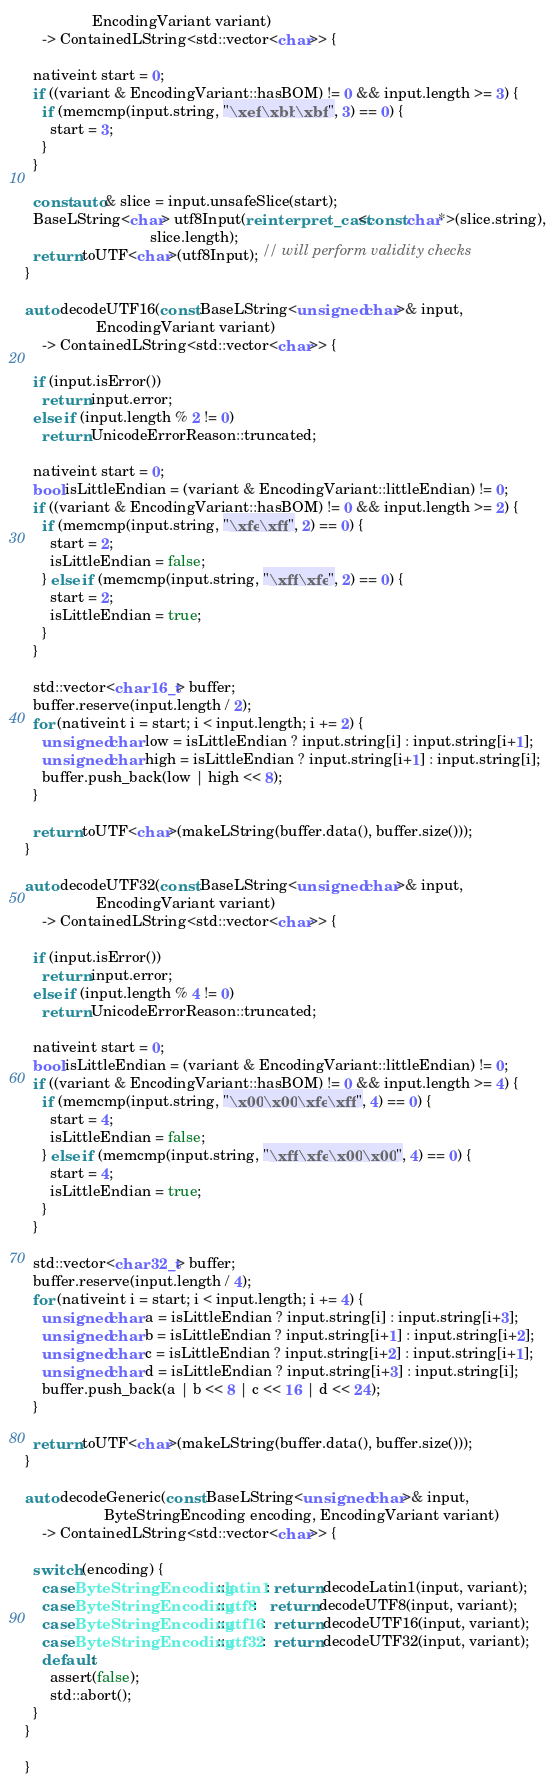<code> <loc_0><loc_0><loc_500><loc_500><_C++_>                EncodingVariant variant)
    -> ContainedLString<std::vector<char>> {

  nativeint start = 0;
  if ((variant & EncodingVariant::hasBOM) != 0 && input.length >= 3) {
    if (memcmp(input.string, "\xef\xbb\xbf", 3) == 0) {
      start = 3;
    }
  }

  const auto& slice = input.unsafeSlice(start);
  BaseLString<char> utf8Input(reinterpret_cast<const char*>(slice.string),
                              slice.length);
  return toUTF<char>(utf8Input); // will perform validity checks
}

auto decodeUTF16(const BaseLString<unsigned char>& input,
                 EncodingVariant variant)
    -> ContainedLString<std::vector<char>> {

  if (input.isError())
    return input.error;
  else if (input.length % 2 != 0)
    return UnicodeErrorReason::truncated;

  nativeint start = 0;
  bool isLittleEndian = (variant & EncodingVariant::littleEndian) != 0;
  if ((variant & EncodingVariant::hasBOM) != 0 && input.length >= 2) {
    if (memcmp(input.string, "\xfe\xff", 2) == 0) {
      start = 2;
      isLittleEndian = false;
    } else if (memcmp(input.string, "\xff\xfe", 2) == 0) {
      start = 2;
      isLittleEndian = true;
    }
  }

  std::vector<char16_t> buffer;
  buffer.reserve(input.length / 2);
  for (nativeint i = start; i < input.length; i += 2) {
    unsigned char low = isLittleEndian ? input.string[i] : input.string[i+1];
    unsigned char high = isLittleEndian ? input.string[i+1] : input.string[i];
    buffer.push_back(low | high << 8);
  }

  return toUTF<char>(makeLString(buffer.data(), buffer.size()));
}

auto decodeUTF32(const BaseLString<unsigned char>& input,
                 EncodingVariant variant)
    -> ContainedLString<std::vector<char>> {

  if (input.isError())
    return input.error;
  else if (input.length % 4 != 0)
    return UnicodeErrorReason::truncated;

  nativeint start = 0;
  bool isLittleEndian = (variant & EncodingVariant::littleEndian) != 0;
  if ((variant & EncodingVariant::hasBOM) != 0 && input.length >= 4) {
    if (memcmp(input.string, "\x00\x00\xfe\xff", 4) == 0) {
      start = 4;
      isLittleEndian = false;
    } else if (memcmp(input.string, "\xff\xfe\x00\x00", 4) == 0) {
      start = 4;
      isLittleEndian = true;
    }
  }

  std::vector<char32_t> buffer;
  buffer.reserve(input.length / 4);
  for (nativeint i = start; i < input.length; i += 4) {
    unsigned char a = isLittleEndian ? input.string[i] : input.string[i+3];
    unsigned char b = isLittleEndian ? input.string[i+1] : input.string[i+2];
    unsigned char c = isLittleEndian ? input.string[i+2] : input.string[i+1];
    unsigned char d = isLittleEndian ? input.string[i+3] : input.string[i];
    buffer.push_back(a | b << 8 | c << 16 | d << 24);
  }

  return toUTF<char>(makeLString(buffer.data(), buffer.size()));
}

auto decodeGeneric(const BaseLString<unsigned char>& input,
                   ByteStringEncoding encoding, EncodingVariant variant)
    -> ContainedLString<std::vector<char>> {

  switch (encoding) {
    case ByteStringEncoding::latin1: return decodeLatin1(input, variant);
    case ByteStringEncoding::utf8:   return decodeUTF8(input, variant);
    case ByteStringEncoding::utf16:  return decodeUTF16(input, variant);
    case ByteStringEncoding::utf32:  return decodeUTF32(input, variant);
    default:
      assert(false);
      std::abort();
  }
}

}
</code> 